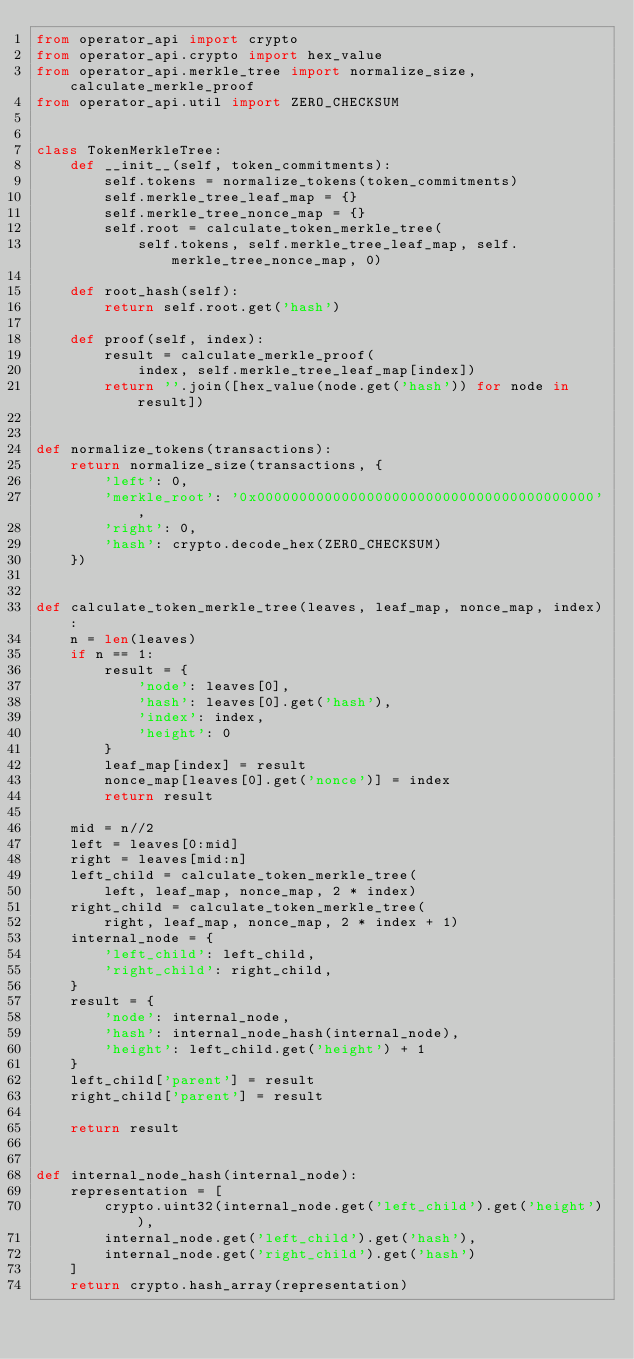<code> <loc_0><loc_0><loc_500><loc_500><_Python_>from operator_api import crypto
from operator_api.crypto import hex_value
from operator_api.merkle_tree import normalize_size, calculate_merkle_proof
from operator_api.util import ZERO_CHECKSUM


class TokenMerkleTree:
    def __init__(self, token_commitments):
        self.tokens = normalize_tokens(token_commitments)
        self.merkle_tree_leaf_map = {}
        self.merkle_tree_nonce_map = {}
        self.root = calculate_token_merkle_tree(
            self.tokens, self.merkle_tree_leaf_map, self.merkle_tree_nonce_map, 0)

    def root_hash(self):
        return self.root.get('hash')

    def proof(self, index):
        result = calculate_merkle_proof(
            index, self.merkle_tree_leaf_map[index])
        return ''.join([hex_value(node.get('hash')) for node in result])


def normalize_tokens(transactions):
    return normalize_size(transactions, {
        'left': 0,
        'merkle_root': '0x0000000000000000000000000000000000000000',
        'right': 0,
        'hash': crypto.decode_hex(ZERO_CHECKSUM)
    })


def calculate_token_merkle_tree(leaves, leaf_map, nonce_map, index):
    n = len(leaves)
    if n == 1:
        result = {
            'node': leaves[0],
            'hash': leaves[0].get('hash'),
            'index': index,
            'height': 0
        }
        leaf_map[index] = result
        nonce_map[leaves[0].get('nonce')] = index
        return result

    mid = n//2
    left = leaves[0:mid]
    right = leaves[mid:n]
    left_child = calculate_token_merkle_tree(
        left, leaf_map, nonce_map, 2 * index)
    right_child = calculate_token_merkle_tree(
        right, leaf_map, nonce_map, 2 * index + 1)
    internal_node = {
        'left_child': left_child,
        'right_child': right_child,
    }
    result = {
        'node': internal_node,
        'hash': internal_node_hash(internal_node),
        'height': left_child.get('height') + 1
    }
    left_child['parent'] = result
    right_child['parent'] = result

    return result


def internal_node_hash(internal_node):
    representation = [
        crypto.uint32(internal_node.get('left_child').get('height')),
        internal_node.get('left_child').get('hash'),
        internal_node.get('right_child').get('hash')
    ]
    return crypto.hash_array(representation)
</code> 